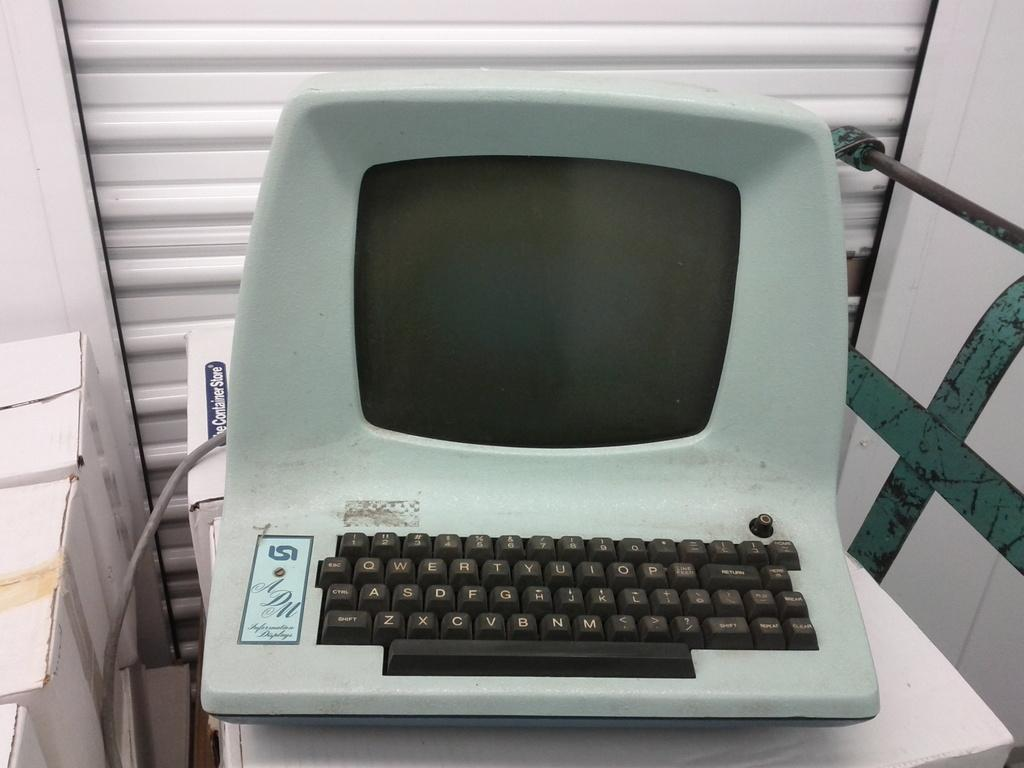<image>
Describe the image concisely. A very old white computer sits on a box from the Container Store. 